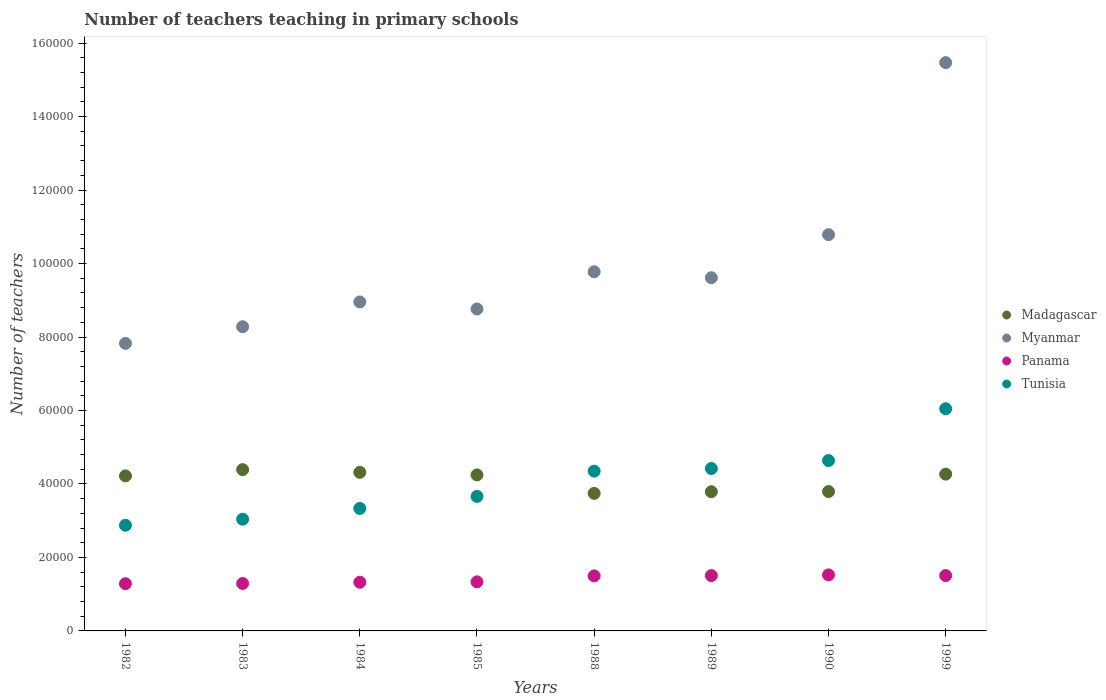What is the number of teachers teaching in primary schools in Tunisia in 1985?
Make the answer very short. 3.66e+04. Across all years, what is the maximum number of teachers teaching in primary schools in Madagascar?
Keep it short and to the point. 4.39e+04. Across all years, what is the minimum number of teachers teaching in primary schools in Tunisia?
Offer a very short reply. 2.88e+04. In which year was the number of teachers teaching in primary schools in Myanmar maximum?
Your response must be concise. 1999. What is the total number of teachers teaching in primary schools in Tunisia in the graph?
Offer a terse response. 3.24e+05. What is the difference between the number of teachers teaching in primary schools in Tunisia in 1984 and that in 1989?
Your response must be concise. -1.09e+04. What is the difference between the number of teachers teaching in primary schools in Myanmar in 1988 and the number of teachers teaching in primary schools in Panama in 1999?
Provide a short and direct response. 8.27e+04. What is the average number of teachers teaching in primary schools in Tunisia per year?
Offer a very short reply. 4.05e+04. In the year 1982, what is the difference between the number of teachers teaching in primary schools in Myanmar and number of teachers teaching in primary schools in Panama?
Keep it short and to the point. 6.54e+04. In how many years, is the number of teachers teaching in primary schools in Myanmar greater than 88000?
Keep it short and to the point. 5. What is the ratio of the number of teachers teaching in primary schools in Madagascar in 1985 to that in 1999?
Your answer should be very brief. 0.99. Is the number of teachers teaching in primary schools in Tunisia in 1984 less than that in 1990?
Your response must be concise. Yes. What is the difference between the highest and the second highest number of teachers teaching in primary schools in Tunisia?
Provide a succinct answer. 1.41e+04. What is the difference between the highest and the lowest number of teachers teaching in primary schools in Tunisia?
Offer a terse response. 3.17e+04. In how many years, is the number of teachers teaching in primary schools in Tunisia greater than the average number of teachers teaching in primary schools in Tunisia taken over all years?
Ensure brevity in your answer.  4. Is the sum of the number of teachers teaching in primary schools in Panama in 1983 and 1989 greater than the maximum number of teachers teaching in primary schools in Madagascar across all years?
Make the answer very short. No. Is it the case that in every year, the sum of the number of teachers teaching in primary schools in Tunisia and number of teachers teaching in primary schools in Madagascar  is greater than the sum of number of teachers teaching in primary schools in Myanmar and number of teachers teaching in primary schools in Panama?
Offer a very short reply. Yes. How many dotlines are there?
Your answer should be very brief. 4. How many years are there in the graph?
Ensure brevity in your answer.  8. Are the values on the major ticks of Y-axis written in scientific E-notation?
Your answer should be compact. No. Does the graph contain grids?
Provide a succinct answer. No. Where does the legend appear in the graph?
Provide a short and direct response. Center right. How are the legend labels stacked?
Make the answer very short. Vertical. What is the title of the graph?
Provide a short and direct response. Number of teachers teaching in primary schools. What is the label or title of the X-axis?
Provide a short and direct response. Years. What is the label or title of the Y-axis?
Make the answer very short. Number of teachers. What is the Number of teachers in Madagascar in 1982?
Keep it short and to the point. 4.22e+04. What is the Number of teachers in Myanmar in 1982?
Your response must be concise. 7.83e+04. What is the Number of teachers in Panama in 1982?
Offer a terse response. 1.29e+04. What is the Number of teachers of Tunisia in 1982?
Offer a very short reply. 2.88e+04. What is the Number of teachers in Madagascar in 1983?
Keep it short and to the point. 4.39e+04. What is the Number of teachers in Myanmar in 1983?
Keep it short and to the point. 8.28e+04. What is the Number of teachers of Panama in 1983?
Ensure brevity in your answer.  1.29e+04. What is the Number of teachers of Tunisia in 1983?
Keep it short and to the point. 3.04e+04. What is the Number of teachers in Madagascar in 1984?
Provide a short and direct response. 4.32e+04. What is the Number of teachers in Myanmar in 1984?
Provide a short and direct response. 8.95e+04. What is the Number of teachers of Panama in 1984?
Keep it short and to the point. 1.33e+04. What is the Number of teachers in Tunisia in 1984?
Your response must be concise. 3.33e+04. What is the Number of teachers of Madagascar in 1985?
Keep it short and to the point. 4.25e+04. What is the Number of teachers of Myanmar in 1985?
Ensure brevity in your answer.  8.76e+04. What is the Number of teachers of Panama in 1985?
Provide a short and direct response. 1.34e+04. What is the Number of teachers in Tunisia in 1985?
Keep it short and to the point. 3.66e+04. What is the Number of teachers of Madagascar in 1988?
Your response must be concise. 3.74e+04. What is the Number of teachers in Myanmar in 1988?
Give a very brief answer. 9.78e+04. What is the Number of teachers in Panama in 1988?
Provide a short and direct response. 1.50e+04. What is the Number of teachers of Tunisia in 1988?
Offer a terse response. 4.35e+04. What is the Number of teachers in Madagascar in 1989?
Your answer should be compact. 3.79e+04. What is the Number of teachers of Myanmar in 1989?
Your answer should be very brief. 9.61e+04. What is the Number of teachers in Panama in 1989?
Offer a very short reply. 1.51e+04. What is the Number of teachers in Tunisia in 1989?
Your answer should be compact. 4.42e+04. What is the Number of teachers in Madagascar in 1990?
Give a very brief answer. 3.79e+04. What is the Number of teachers in Myanmar in 1990?
Give a very brief answer. 1.08e+05. What is the Number of teachers in Panama in 1990?
Keep it short and to the point. 1.52e+04. What is the Number of teachers in Tunisia in 1990?
Provide a succinct answer. 4.64e+04. What is the Number of teachers in Madagascar in 1999?
Provide a succinct answer. 4.27e+04. What is the Number of teachers in Myanmar in 1999?
Offer a very short reply. 1.55e+05. What is the Number of teachers of Panama in 1999?
Your answer should be compact. 1.51e+04. What is the Number of teachers in Tunisia in 1999?
Offer a very short reply. 6.05e+04. Across all years, what is the maximum Number of teachers of Madagascar?
Your answer should be compact. 4.39e+04. Across all years, what is the maximum Number of teachers in Myanmar?
Your answer should be very brief. 1.55e+05. Across all years, what is the maximum Number of teachers of Panama?
Offer a terse response. 1.52e+04. Across all years, what is the maximum Number of teachers of Tunisia?
Keep it short and to the point. 6.05e+04. Across all years, what is the minimum Number of teachers in Madagascar?
Offer a very short reply. 3.74e+04. Across all years, what is the minimum Number of teachers of Myanmar?
Ensure brevity in your answer.  7.83e+04. Across all years, what is the minimum Number of teachers in Panama?
Make the answer very short. 1.29e+04. Across all years, what is the minimum Number of teachers of Tunisia?
Provide a succinct answer. 2.88e+04. What is the total Number of teachers in Madagascar in the graph?
Give a very brief answer. 3.28e+05. What is the total Number of teachers in Myanmar in the graph?
Offer a terse response. 7.95e+05. What is the total Number of teachers in Panama in the graph?
Make the answer very short. 1.13e+05. What is the total Number of teachers in Tunisia in the graph?
Offer a very short reply. 3.24e+05. What is the difference between the Number of teachers in Madagascar in 1982 and that in 1983?
Provide a short and direct response. -1701. What is the difference between the Number of teachers in Myanmar in 1982 and that in 1983?
Make the answer very short. -4534. What is the difference between the Number of teachers in Panama in 1982 and that in 1983?
Keep it short and to the point. -59. What is the difference between the Number of teachers in Tunisia in 1982 and that in 1983?
Offer a very short reply. -1647. What is the difference between the Number of teachers in Madagascar in 1982 and that in 1984?
Your answer should be compact. -960. What is the difference between the Number of teachers in Myanmar in 1982 and that in 1984?
Your answer should be very brief. -1.13e+04. What is the difference between the Number of teachers of Panama in 1982 and that in 1984?
Make the answer very short. -402. What is the difference between the Number of teachers of Tunisia in 1982 and that in 1984?
Provide a succinct answer. -4583. What is the difference between the Number of teachers of Madagascar in 1982 and that in 1985?
Your response must be concise. -265. What is the difference between the Number of teachers in Myanmar in 1982 and that in 1985?
Your answer should be very brief. -9366. What is the difference between the Number of teachers in Panama in 1982 and that in 1985?
Make the answer very short. -506. What is the difference between the Number of teachers in Tunisia in 1982 and that in 1985?
Your answer should be very brief. -7846. What is the difference between the Number of teachers of Madagascar in 1982 and that in 1988?
Ensure brevity in your answer.  4758. What is the difference between the Number of teachers of Myanmar in 1982 and that in 1988?
Your answer should be very brief. -1.95e+04. What is the difference between the Number of teachers in Panama in 1982 and that in 1988?
Make the answer very short. -2127. What is the difference between the Number of teachers in Tunisia in 1982 and that in 1988?
Ensure brevity in your answer.  -1.47e+04. What is the difference between the Number of teachers of Madagascar in 1982 and that in 1989?
Provide a succinct answer. 4303. What is the difference between the Number of teachers of Myanmar in 1982 and that in 1989?
Offer a very short reply. -1.79e+04. What is the difference between the Number of teachers of Panama in 1982 and that in 1989?
Provide a short and direct response. -2209. What is the difference between the Number of teachers of Tunisia in 1982 and that in 1989?
Your answer should be very brief. -1.54e+04. What is the difference between the Number of teachers of Madagascar in 1982 and that in 1990?
Give a very brief answer. 4265. What is the difference between the Number of teachers of Myanmar in 1982 and that in 1990?
Offer a very short reply. -2.96e+04. What is the difference between the Number of teachers of Panama in 1982 and that in 1990?
Your answer should be very brief. -2396. What is the difference between the Number of teachers in Tunisia in 1982 and that in 1990?
Give a very brief answer. -1.76e+04. What is the difference between the Number of teachers of Madagascar in 1982 and that in 1999?
Give a very brief answer. -481. What is the difference between the Number of teachers in Myanmar in 1982 and that in 1999?
Your answer should be compact. -7.64e+04. What is the difference between the Number of teachers in Panama in 1982 and that in 1999?
Offer a very short reply. -2216. What is the difference between the Number of teachers in Tunisia in 1982 and that in 1999?
Offer a very short reply. -3.17e+04. What is the difference between the Number of teachers in Madagascar in 1983 and that in 1984?
Ensure brevity in your answer.  741. What is the difference between the Number of teachers in Myanmar in 1983 and that in 1984?
Provide a succinct answer. -6740. What is the difference between the Number of teachers in Panama in 1983 and that in 1984?
Your answer should be very brief. -343. What is the difference between the Number of teachers in Tunisia in 1983 and that in 1984?
Provide a short and direct response. -2936. What is the difference between the Number of teachers of Madagascar in 1983 and that in 1985?
Ensure brevity in your answer.  1436. What is the difference between the Number of teachers of Myanmar in 1983 and that in 1985?
Keep it short and to the point. -4832. What is the difference between the Number of teachers in Panama in 1983 and that in 1985?
Provide a succinct answer. -447. What is the difference between the Number of teachers in Tunisia in 1983 and that in 1985?
Offer a very short reply. -6199. What is the difference between the Number of teachers in Madagascar in 1983 and that in 1988?
Offer a very short reply. 6459. What is the difference between the Number of teachers in Myanmar in 1983 and that in 1988?
Offer a very short reply. -1.50e+04. What is the difference between the Number of teachers in Panama in 1983 and that in 1988?
Provide a short and direct response. -2068. What is the difference between the Number of teachers of Tunisia in 1983 and that in 1988?
Your answer should be very brief. -1.31e+04. What is the difference between the Number of teachers of Madagascar in 1983 and that in 1989?
Your response must be concise. 6004. What is the difference between the Number of teachers in Myanmar in 1983 and that in 1989?
Keep it short and to the point. -1.33e+04. What is the difference between the Number of teachers of Panama in 1983 and that in 1989?
Keep it short and to the point. -2150. What is the difference between the Number of teachers in Tunisia in 1983 and that in 1989?
Make the answer very short. -1.38e+04. What is the difference between the Number of teachers of Madagascar in 1983 and that in 1990?
Your answer should be very brief. 5966. What is the difference between the Number of teachers in Myanmar in 1983 and that in 1990?
Your response must be concise. -2.51e+04. What is the difference between the Number of teachers in Panama in 1983 and that in 1990?
Your response must be concise. -2337. What is the difference between the Number of teachers of Tunisia in 1983 and that in 1990?
Offer a terse response. -1.60e+04. What is the difference between the Number of teachers of Madagascar in 1983 and that in 1999?
Offer a very short reply. 1220. What is the difference between the Number of teachers of Myanmar in 1983 and that in 1999?
Offer a terse response. -7.19e+04. What is the difference between the Number of teachers in Panama in 1983 and that in 1999?
Offer a terse response. -2157. What is the difference between the Number of teachers of Tunisia in 1983 and that in 1999?
Make the answer very short. -3.01e+04. What is the difference between the Number of teachers in Madagascar in 1984 and that in 1985?
Keep it short and to the point. 695. What is the difference between the Number of teachers of Myanmar in 1984 and that in 1985?
Offer a terse response. 1908. What is the difference between the Number of teachers in Panama in 1984 and that in 1985?
Make the answer very short. -104. What is the difference between the Number of teachers in Tunisia in 1984 and that in 1985?
Keep it short and to the point. -3263. What is the difference between the Number of teachers of Madagascar in 1984 and that in 1988?
Provide a short and direct response. 5718. What is the difference between the Number of teachers of Myanmar in 1984 and that in 1988?
Ensure brevity in your answer.  -8224. What is the difference between the Number of teachers of Panama in 1984 and that in 1988?
Make the answer very short. -1725. What is the difference between the Number of teachers in Tunisia in 1984 and that in 1988?
Offer a very short reply. -1.01e+04. What is the difference between the Number of teachers of Madagascar in 1984 and that in 1989?
Your answer should be very brief. 5263. What is the difference between the Number of teachers of Myanmar in 1984 and that in 1989?
Provide a short and direct response. -6600. What is the difference between the Number of teachers of Panama in 1984 and that in 1989?
Give a very brief answer. -1807. What is the difference between the Number of teachers in Tunisia in 1984 and that in 1989?
Provide a short and direct response. -1.09e+04. What is the difference between the Number of teachers in Madagascar in 1984 and that in 1990?
Your answer should be very brief. 5225. What is the difference between the Number of teachers in Myanmar in 1984 and that in 1990?
Keep it short and to the point. -1.83e+04. What is the difference between the Number of teachers in Panama in 1984 and that in 1990?
Make the answer very short. -1994. What is the difference between the Number of teachers of Tunisia in 1984 and that in 1990?
Your answer should be compact. -1.30e+04. What is the difference between the Number of teachers in Madagascar in 1984 and that in 1999?
Ensure brevity in your answer.  479. What is the difference between the Number of teachers of Myanmar in 1984 and that in 1999?
Make the answer very short. -6.51e+04. What is the difference between the Number of teachers of Panama in 1984 and that in 1999?
Make the answer very short. -1814. What is the difference between the Number of teachers in Tunisia in 1984 and that in 1999?
Your answer should be very brief. -2.71e+04. What is the difference between the Number of teachers of Madagascar in 1985 and that in 1988?
Your answer should be compact. 5023. What is the difference between the Number of teachers of Myanmar in 1985 and that in 1988?
Your response must be concise. -1.01e+04. What is the difference between the Number of teachers of Panama in 1985 and that in 1988?
Your answer should be very brief. -1621. What is the difference between the Number of teachers in Tunisia in 1985 and that in 1988?
Provide a succinct answer. -6880. What is the difference between the Number of teachers in Madagascar in 1985 and that in 1989?
Make the answer very short. 4568. What is the difference between the Number of teachers in Myanmar in 1985 and that in 1989?
Offer a very short reply. -8508. What is the difference between the Number of teachers in Panama in 1985 and that in 1989?
Your response must be concise. -1703. What is the difference between the Number of teachers of Tunisia in 1985 and that in 1989?
Your answer should be compact. -7598. What is the difference between the Number of teachers of Madagascar in 1985 and that in 1990?
Keep it short and to the point. 4530. What is the difference between the Number of teachers in Myanmar in 1985 and that in 1990?
Offer a very short reply. -2.02e+04. What is the difference between the Number of teachers of Panama in 1985 and that in 1990?
Provide a short and direct response. -1890. What is the difference between the Number of teachers of Tunisia in 1985 and that in 1990?
Your answer should be compact. -9756. What is the difference between the Number of teachers of Madagascar in 1985 and that in 1999?
Make the answer very short. -216. What is the difference between the Number of teachers of Myanmar in 1985 and that in 1999?
Your answer should be very brief. -6.71e+04. What is the difference between the Number of teachers in Panama in 1985 and that in 1999?
Provide a succinct answer. -1710. What is the difference between the Number of teachers of Tunisia in 1985 and that in 1999?
Your response must be concise. -2.39e+04. What is the difference between the Number of teachers in Madagascar in 1988 and that in 1989?
Provide a succinct answer. -455. What is the difference between the Number of teachers in Myanmar in 1988 and that in 1989?
Make the answer very short. 1624. What is the difference between the Number of teachers in Panama in 1988 and that in 1989?
Give a very brief answer. -82. What is the difference between the Number of teachers of Tunisia in 1988 and that in 1989?
Ensure brevity in your answer.  -718. What is the difference between the Number of teachers in Madagascar in 1988 and that in 1990?
Provide a succinct answer. -493. What is the difference between the Number of teachers in Myanmar in 1988 and that in 1990?
Keep it short and to the point. -1.01e+04. What is the difference between the Number of teachers in Panama in 1988 and that in 1990?
Give a very brief answer. -269. What is the difference between the Number of teachers of Tunisia in 1988 and that in 1990?
Provide a succinct answer. -2876. What is the difference between the Number of teachers in Madagascar in 1988 and that in 1999?
Ensure brevity in your answer.  -5239. What is the difference between the Number of teachers in Myanmar in 1988 and that in 1999?
Your response must be concise. -5.69e+04. What is the difference between the Number of teachers of Panama in 1988 and that in 1999?
Make the answer very short. -89. What is the difference between the Number of teachers in Tunisia in 1988 and that in 1999?
Provide a succinct answer. -1.70e+04. What is the difference between the Number of teachers in Madagascar in 1989 and that in 1990?
Offer a very short reply. -38. What is the difference between the Number of teachers in Myanmar in 1989 and that in 1990?
Provide a succinct answer. -1.17e+04. What is the difference between the Number of teachers of Panama in 1989 and that in 1990?
Offer a very short reply. -187. What is the difference between the Number of teachers in Tunisia in 1989 and that in 1990?
Provide a succinct answer. -2158. What is the difference between the Number of teachers of Madagascar in 1989 and that in 1999?
Provide a succinct answer. -4784. What is the difference between the Number of teachers of Myanmar in 1989 and that in 1999?
Offer a very short reply. -5.85e+04. What is the difference between the Number of teachers of Panama in 1989 and that in 1999?
Make the answer very short. -7. What is the difference between the Number of teachers of Tunisia in 1989 and that in 1999?
Your response must be concise. -1.63e+04. What is the difference between the Number of teachers of Madagascar in 1990 and that in 1999?
Give a very brief answer. -4746. What is the difference between the Number of teachers of Myanmar in 1990 and that in 1999?
Offer a terse response. -4.68e+04. What is the difference between the Number of teachers in Panama in 1990 and that in 1999?
Provide a short and direct response. 180. What is the difference between the Number of teachers in Tunisia in 1990 and that in 1999?
Provide a succinct answer. -1.41e+04. What is the difference between the Number of teachers in Madagascar in 1982 and the Number of teachers in Myanmar in 1983?
Make the answer very short. -4.06e+04. What is the difference between the Number of teachers in Madagascar in 1982 and the Number of teachers in Panama in 1983?
Your response must be concise. 2.93e+04. What is the difference between the Number of teachers in Madagascar in 1982 and the Number of teachers in Tunisia in 1983?
Offer a terse response. 1.18e+04. What is the difference between the Number of teachers in Myanmar in 1982 and the Number of teachers in Panama in 1983?
Give a very brief answer. 6.54e+04. What is the difference between the Number of teachers in Myanmar in 1982 and the Number of teachers in Tunisia in 1983?
Make the answer very short. 4.79e+04. What is the difference between the Number of teachers of Panama in 1982 and the Number of teachers of Tunisia in 1983?
Your answer should be very brief. -1.76e+04. What is the difference between the Number of teachers of Madagascar in 1982 and the Number of teachers of Myanmar in 1984?
Keep it short and to the point. -4.73e+04. What is the difference between the Number of teachers of Madagascar in 1982 and the Number of teachers of Panama in 1984?
Offer a terse response. 2.89e+04. What is the difference between the Number of teachers in Madagascar in 1982 and the Number of teachers in Tunisia in 1984?
Provide a succinct answer. 8850. What is the difference between the Number of teachers of Myanmar in 1982 and the Number of teachers of Panama in 1984?
Your answer should be compact. 6.50e+04. What is the difference between the Number of teachers of Myanmar in 1982 and the Number of teachers of Tunisia in 1984?
Offer a very short reply. 4.49e+04. What is the difference between the Number of teachers in Panama in 1982 and the Number of teachers in Tunisia in 1984?
Your response must be concise. -2.05e+04. What is the difference between the Number of teachers in Madagascar in 1982 and the Number of teachers in Myanmar in 1985?
Offer a very short reply. -4.54e+04. What is the difference between the Number of teachers in Madagascar in 1982 and the Number of teachers in Panama in 1985?
Give a very brief answer. 2.88e+04. What is the difference between the Number of teachers in Madagascar in 1982 and the Number of teachers in Tunisia in 1985?
Your response must be concise. 5587. What is the difference between the Number of teachers in Myanmar in 1982 and the Number of teachers in Panama in 1985?
Give a very brief answer. 6.49e+04. What is the difference between the Number of teachers in Myanmar in 1982 and the Number of teachers in Tunisia in 1985?
Your answer should be very brief. 4.17e+04. What is the difference between the Number of teachers of Panama in 1982 and the Number of teachers of Tunisia in 1985?
Provide a short and direct response. -2.38e+04. What is the difference between the Number of teachers of Madagascar in 1982 and the Number of teachers of Myanmar in 1988?
Provide a short and direct response. -5.56e+04. What is the difference between the Number of teachers of Madagascar in 1982 and the Number of teachers of Panama in 1988?
Offer a terse response. 2.72e+04. What is the difference between the Number of teachers of Madagascar in 1982 and the Number of teachers of Tunisia in 1988?
Your response must be concise. -1293. What is the difference between the Number of teachers of Myanmar in 1982 and the Number of teachers of Panama in 1988?
Ensure brevity in your answer.  6.33e+04. What is the difference between the Number of teachers in Myanmar in 1982 and the Number of teachers in Tunisia in 1988?
Offer a terse response. 3.48e+04. What is the difference between the Number of teachers in Panama in 1982 and the Number of teachers in Tunisia in 1988?
Ensure brevity in your answer.  -3.06e+04. What is the difference between the Number of teachers of Madagascar in 1982 and the Number of teachers of Myanmar in 1989?
Make the answer very short. -5.39e+04. What is the difference between the Number of teachers in Madagascar in 1982 and the Number of teachers in Panama in 1989?
Make the answer very short. 2.71e+04. What is the difference between the Number of teachers in Madagascar in 1982 and the Number of teachers in Tunisia in 1989?
Provide a succinct answer. -2011. What is the difference between the Number of teachers of Myanmar in 1982 and the Number of teachers of Panama in 1989?
Make the answer very short. 6.32e+04. What is the difference between the Number of teachers in Myanmar in 1982 and the Number of teachers in Tunisia in 1989?
Ensure brevity in your answer.  3.41e+04. What is the difference between the Number of teachers in Panama in 1982 and the Number of teachers in Tunisia in 1989?
Give a very brief answer. -3.14e+04. What is the difference between the Number of teachers in Madagascar in 1982 and the Number of teachers in Myanmar in 1990?
Offer a very short reply. -6.57e+04. What is the difference between the Number of teachers in Madagascar in 1982 and the Number of teachers in Panama in 1990?
Your response must be concise. 2.69e+04. What is the difference between the Number of teachers of Madagascar in 1982 and the Number of teachers of Tunisia in 1990?
Your response must be concise. -4169. What is the difference between the Number of teachers in Myanmar in 1982 and the Number of teachers in Panama in 1990?
Your answer should be compact. 6.30e+04. What is the difference between the Number of teachers of Myanmar in 1982 and the Number of teachers of Tunisia in 1990?
Give a very brief answer. 3.19e+04. What is the difference between the Number of teachers of Panama in 1982 and the Number of teachers of Tunisia in 1990?
Your answer should be very brief. -3.35e+04. What is the difference between the Number of teachers of Madagascar in 1982 and the Number of teachers of Myanmar in 1999?
Provide a short and direct response. -1.12e+05. What is the difference between the Number of teachers in Madagascar in 1982 and the Number of teachers in Panama in 1999?
Provide a succinct answer. 2.71e+04. What is the difference between the Number of teachers of Madagascar in 1982 and the Number of teachers of Tunisia in 1999?
Your answer should be very brief. -1.83e+04. What is the difference between the Number of teachers of Myanmar in 1982 and the Number of teachers of Panama in 1999?
Give a very brief answer. 6.32e+04. What is the difference between the Number of teachers of Myanmar in 1982 and the Number of teachers of Tunisia in 1999?
Provide a short and direct response. 1.78e+04. What is the difference between the Number of teachers in Panama in 1982 and the Number of teachers in Tunisia in 1999?
Provide a succinct answer. -4.76e+04. What is the difference between the Number of teachers of Madagascar in 1983 and the Number of teachers of Myanmar in 1984?
Give a very brief answer. -4.56e+04. What is the difference between the Number of teachers in Madagascar in 1983 and the Number of teachers in Panama in 1984?
Keep it short and to the point. 3.06e+04. What is the difference between the Number of teachers in Madagascar in 1983 and the Number of teachers in Tunisia in 1984?
Offer a very short reply. 1.06e+04. What is the difference between the Number of teachers in Myanmar in 1983 and the Number of teachers in Panama in 1984?
Offer a very short reply. 6.95e+04. What is the difference between the Number of teachers of Myanmar in 1983 and the Number of teachers of Tunisia in 1984?
Offer a very short reply. 4.95e+04. What is the difference between the Number of teachers of Panama in 1983 and the Number of teachers of Tunisia in 1984?
Ensure brevity in your answer.  -2.04e+04. What is the difference between the Number of teachers of Madagascar in 1983 and the Number of teachers of Myanmar in 1985?
Offer a very short reply. -4.37e+04. What is the difference between the Number of teachers of Madagascar in 1983 and the Number of teachers of Panama in 1985?
Ensure brevity in your answer.  3.05e+04. What is the difference between the Number of teachers in Madagascar in 1983 and the Number of teachers in Tunisia in 1985?
Make the answer very short. 7288. What is the difference between the Number of teachers of Myanmar in 1983 and the Number of teachers of Panama in 1985?
Make the answer very short. 6.94e+04. What is the difference between the Number of teachers of Myanmar in 1983 and the Number of teachers of Tunisia in 1985?
Your answer should be very brief. 4.62e+04. What is the difference between the Number of teachers in Panama in 1983 and the Number of teachers in Tunisia in 1985?
Provide a short and direct response. -2.37e+04. What is the difference between the Number of teachers in Madagascar in 1983 and the Number of teachers in Myanmar in 1988?
Ensure brevity in your answer.  -5.39e+04. What is the difference between the Number of teachers in Madagascar in 1983 and the Number of teachers in Panama in 1988?
Keep it short and to the point. 2.89e+04. What is the difference between the Number of teachers of Madagascar in 1983 and the Number of teachers of Tunisia in 1988?
Offer a very short reply. 408. What is the difference between the Number of teachers of Myanmar in 1983 and the Number of teachers of Panama in 1988?
Offer a terse response. 6.78e+04. What is the difference between the Number of teachers of Myanmar in 1983 and the Number of teachers of Tunisia in 1988?
Provide a short and direct response. 3.93e+04. What is the difference between the Number of teachers of Panama in 1983 and the Number of teachers of Tunisia in 1988?
Ensure brevity in your answer.  -3.06e+04. What is the difference between the Number of teachers of Madagascar in 1983 and the Number of teachers of Myanmar in 1989?
Give a very brief answer. -5.22e+04. What is the difference between the Number of teachers of Madagascar in 1983 and the Number of teachers of Panama in 1989?
Make the answer very short. 2.88e+04. What is the difference between the Number of teachers in Madagascar in 1983 and the Number of teachers in Tunisia in 1989?
Provide a succinct answer. -310. What is the difference between the Number of teachers in Myanmar in 1983 and the Number of teachers in Panama in 1989?
Your response must be concise. 6.77e+04. What is the difference between the Number of teachers of Myanmar in 1983 and the Number of teachers of Tunisia in 1989?
Your answer should be compact. 3.86e+04. What is the difference between the Number of teachers of Panama in 1983 and the Number of teachers of Tunisia in 1989?
Make the answer very short. -3.13e+04. What is the difference between the Number of teachers in Madagascar in 1983 and the Number of teachers in Myanmar in 1990?
Provide a short and direct response. -6.40e+04. What is the difference between the Number of teachers in Madagascar in 1983 and the Number of teachers in Panama in 1990?
Provide a succinct answer. 2.86e+04. What is the difference between the Number of teachers in Madagascar in 1983 and the Number of teachers in Tunisia in 1990?
Give a very brief answer. -2468. What is the difference between the Number of teachers in Myanmar in 1983 and the Number of teachers in Panama in 1990?
Offer a very short reply. 6.76e+04. What is the difference between the Number of teachers in Myanmar in 1983 and the Number of teachers in Tunisia in 1990?
Offer a very short reply. 3.64e+04. What is the difference between the Number of teachers of Panama in 1983 and the Number of teachers of Tunisia in 1990?
Your response must be concise. -3.35e+04. What is the difference between the Number of teachers in Madagascar in 1983 and the Number of teachers in Myanmar in 1999?
Offer a very short reply. -1.11e+05. What is the difference between the Number of teachers in Madagascar in 1983 and the Number of teachers in Panama in 1999?
Offer a very short reply. 2.88e+04. What is the difference between the Number of teachers in Madagascar in 1983 and the Number of teachers in Tunisia in 1999?
Provide a short and direct response. -1.66e+04. What is the difference between the Number of teachers of Myanmar in 1983 and the Number of teachers of Panama in 1999?
Your answer should be compact. 6.77e+04. What is the difference between the Number of teachers in Myanmar in 1983 and the Number of teachers in Tunisia in 1999?
Your answer should be compact. 2.23e+04. What is the difference between the Number of teachers in Panama in 1983 and the Number of teachers in Tunisia in 1999?
Ensure brevity in your answer.  -4.76e+04. What is the difference between the Number of teachers in Madagascar in 1984 and the Number of teachers in Myanmar in 1985?
Your answer should be very brief. -4.45e+04. What is the difference between the Number of teachers of Madagascar in 1984 and the Number of teachers of Panama in 1985?
Your answer should be compact. 2.98e+04. What is the difference between the Number of teachers of Madagascar in 1984 and the Number of teachers of Tunisia in 1985?
Keep it short and to the point. 6547. What is the difference between the Number of teachers in Myanmar in 1984 and the Number of teachers in Panama in 1985?
Keep it short and to the point. 7.62e+04. What is the difference between the Number of teachers in Myanmar in 1984 and the Number of teachers in Tunisia in 1985?
Keep it short and to the point. 5.29e+04. What is the difference between the Number of teachers of Panama in 1984 and the Number of teachers of Tunisia in 1985?
Make the answer very short. -2.34e+04. What is the difference between the Number of teachers in Madagascar in 1984 and the Number of teachers in Myanmar in 1988?
Make the answer very short. -5.46e+04. What is the difference between the Number of teachers in Madagascar in 1984 and the Number of teachers in Panama in 1988?
Give a very brief answer. 2.82e+04. What is the difference between the Number of teachers in Madagascar in 1984 and the Number of teachers in Tunisia in 1988?
Make the answer very short. -333. What is the difference between the Number of teachers of Myanmar in 1984 and the Number of teachers of Panama in 1988?
Keep it short and to the point. 7.46e+04. What is the difference between the Number of teachers of Myanmar in 1984 and the Number of teachers of Tunisia in 1988?
Keep it short and to the point. 4.60e+04. What is the difference between the Number of teachers in Panama in 1984 and the Number of teachers in Tunisia in 1988?
Your answer should be very brief. -3.02e+04. What is the difference between the Number of teachers of Madagascar in 1984 and the Number of teachers of Myanmar in 1989?
Give a very brief answer. -5.30e+04. What is the difference between the Number of teachers of Madagascar in 1984 and the Number of teachers of Panama in 1989?
Your answer should be compact. 2.81e+04. What is the difference between the Number of teachers in Madagascar in 1984 and the Number of teachers in Tunisia in 1989?
Your answer should be compact. -1051. What is the difference between the Number of teachers of Myanmar in 1984 and the Number of teachers of Panama in 1989?
Provide a succinct answer. 7.45e+04. What is the difference between the Number of teachers in Myanmar in 1984 and the Number of teachers in Tunisia in 1989?
Your answer should be very brief. 4.53e+04. What is the difference between the Number of teachers of Panama in 1984 and the Number of teachers of Tunisia in 1989?
Offer a very short reply. -3.10e+04. What is the difference between the Number of teachers of Madagascar in 1984 and the Number of teachers of Myanmar in 1990?
Make the answer very short. -6.47e+04. What is the difference between the Number of teachers of Madagascar in 1984 and the Number of teachers of Panama in 1990?
Your answer should be very brief. 2.79e+04. What is the difference between the Number of teachers in Madagascar in 1984 and the Number of teachers in Tunisia in 1990?
Your response must be concise. -3209. What is the difference between the Number of teachers of Myanmar in 1984 and the Number of teachers of Panama in 1990?
Make the answer very short. 7.43e+04. What is the difference between the Number of teachers of Myanmar in 1984 and the Number of teachers of Tunisia in 1990?
Offer a very short reply. 4.32e+04. What is the difference between the Number of teachers in Panama in 1984 and the Number of teachers in Tunisia in 1990?
Keep it short and to the point. -3.31e+04. What is the difference between the Number of teachers in Madagascar in 1984 and the Number of teachers in Myanmar in 1999?
Make the answer very short. -1.12e+05. What is the difference between the Number of teachers in Madagascar in 1984 and the Number of teachers in Panama in 1999?
Offer a very short reply. 2.81e+04. What is the difference between the Number of teachers in Madagascar in 1984 and the Number of teachers in Tunisia in 1999?
Provide a succinct answer. -1.73e+04. What is the difference between the Number of teachers in Myanmar in 1984 and the Number of teachers in Panama in 1999?
Your response must be concise. 7.45e+04. What is the difference between the Number of teachers in Myanmar in 1984 and the Number of teachers in Tunisia in 1999?
Offer a very short reply. 2.91e+04. What is the difference between the Number of teachers in Panama in 1984 and the Number of teachers in Tunisia in 1999?
Provide a short and direct response. -4.72e+04. What is the difference between the Number of teachers in Madagascar in 1985 and the Number of teachers in Myanmar in 1988?
Offer a very short reply. -5.53e+04. What is the difference between the Number of teachers of Madagascar in 1985 and the Number of teachers of Panama in 1988?
Your answer should be compact. 2.75e+04. What is the difference between the Number of teachers in Madagascar in 1985 and the Number of teachers in Tunisia in 1988?
Make the answer very short. -1028. What is the difference between the Number of teachers in Myanmar in 1985 and the Number of teachers in Panama in 1988?
Make the answer very short. 7.27e+04. What is the difference between the Number of teachers of Myanmar in 1985 and the Number of teachers of Tunisia in 1988?
Ensure brevity in your answer.  4.41e+04. What is the difference between the Number of teachers in Panama in 1985 and the Number of teachers in Tunisia in 1988?
Give a very brief answer. -3.01e+04. What is the difference between the Number of teachers of Madagascar in 1985 and the Number of teachers of Myanmar in 1989?
Offer a terse response. -5.37e+04. What is the difference between the Number of teachers of Madagascar in 1985 and the Number of teachers of Panama in 1989?
Your response must be concise. 2.74e+04. What is the difference between the Number of teachers of Madagascar in 1985 and the Number of teachers of Tunisia in 1989?
Your answer should be compact. -1746. What is the difference between the Number of teachers in Myanmar in 1985 and the Number of teachers in Panama in 1989?
Your response must be concise. 7.26e+04. What is the difference between the Number of teachers of Myanmar in 1985 and the Number of teachers of Tunisia in 1989?
Ensure brevity in your answer.  4.34e+04. What is the difference between the Number of teachers in Panama in 1985 and the Number of teachers in Tunisia in 1989?
Your answer should be compact. -3.08e+04. What is the difference between the Number of teachers in Madagascar in 1985 and the Number of teachers in Myanmar in 1990?
Provide a short and direct response. -6.54e+04. What is the difference between the Number of teachers of Madagascar in 1985 and the Number of teachers of Panama in 1990?
Offer a terse response. 2.72e+04. What is the difference between the Number of teachers in Madagascar in 1985 and the Number of teachers in Tunisia in 1990?
Offer a very short reply. -3904. What is the difference between the Number of teachers of Myanmar in 1985 and the Number of teachers of Panama in 1990?
Offer a very short reply. 7.24e+04. What is the difference between the Number of teachers in Myanmar in 1985 and the Number of teachers in Tunisia in 1990?
Offer a very short reply. 4.13e+04. What is the difference between the Number of teachers in Panama in 1985 and the Number of teachers in Tunisia in 1990?
Your answer should be very brief. -3.30e+04. What is the difference between the Number of teachers of Madagascar in 1985 and the Number of teachers of Myanmar in 1999?
Your answer should be compact. -1.12e+05. What is the difference between the Number of teachers in Madagascar in 1985 and the Number of teachers in Panama in 1999?
Your answer should be compact. 2.74e+04. What is the difference between the Number of teachers of Madagascar in 1985 and the Number of teachers of Tunisia in 1999?
Your answer should be very brief. -1.80e+04. What is the difference between the Number of teachers in Myanmar in 1985 and the Number of teachers in Panama in 1999?
Offer a terse response. 7.26e+04. What is the difference between the Number of teachers of Myanmar in 1985 and the Number of teachers of Tunisia in 1999?
Your answer should be compact. 2.72e+04. What is the difference between the Number of teachers in Panama in 1985 and the Number of teachers in Tunisia in 1999?
Ensure brevity in your answer.  -4.71e+04. What is the difference between the Number of teachers in Madagascar in 1988 and the Number of teachers in Myanmar in 1989?
Keep it short and to the point. -5.87e+04. What is the difference between the Number of teachers in Madagascar in 1988 and the Number of teachers in Panama in 1989?
Offer a very short reply. 2.24e+04. What is the difference between the Number of teachers of Madagascar in 1988 and the Number of teachers of Tunisia in 1989?
Your answer should be compact. -6769. What is the difference between the Number of teachers of Myanmar in 1988 and the Number of teachers of Panama in 1989?
Provide a succinct answer. 8.27e+04. What is the difference between the Number of teachers of Myanmar in 1988 and the Number of teachers of Tunisia in 1989?
Your answer should be compact. 5.36e+04. What is the difference between the Number of teachers in Panama in 1988 and the Number of teachers in Tunisia in 1989?
Give a very brief answer. -2.92e+04. What is the difference between the Number of teachers of Madagascar in 1988 and the Number of teachers of Myanmar in 1990?
Provide a succinct answer. -7.04e+04. What is the difference between the Number of teachers in Madagascar in 1988 and the Number of teachers in Panama in 1990?
Provide a short and direct response. 2.22e+04. What is the difference between the Number of teachers of Madagascar in 1988 and the Number of teachers of Tunisia in 1990?
Your answer should be very brief. -8927. What is the difference between the Number of teachers in Myanmar in 1988 and the Number of teachers in Panama in 1990?
Give a very brief answer. 8.25e+04. What is the difference between the Number of teachers in Myanmar in 1988 and the Number of teachers in Tunisia in 1990?
Ensure brevity in your answer.  5.14e+04. What is the difference between the Number of teachers in Panama in 1988 and the Number of teachers in Tunisia in 1990?
Offer a very short reply. -3.14e+04. What is the difference between the Number of teachers in Madagascar in 1988 and the Number of teachers in Myanmar in 1999?
Provide a short and direct response. -1.17e+05. What is the difference between the Number of teachers of Madagascar in 1988 and the Number of teachers of Panama in 1999?
Give a very brief answer. 2.24e+04. What is the difference between the Number of teachers in Madagascar in 1988 and the Number of teachers in Tunisia in 1999?
Offer a very short reply. -2.30e+04. What is the difference between the Number of teachers in Myanmar in 1988 and the Number of teachers in Panama in 1999?
Make the answer very short. 8.27e+04. What is the difference between the Number of teachers in Myanmar in 1988 and the Number of teachers in Tunisia in 1999?
Keep it short and to the point. 3.73e+04. What is the difference between the Number of teachers in Panama in 1988 and the Number of teachers in Tunisia in 1999?
Provide a short and direct response. -4.55e+04. What is the difference between the Number of teachers of Madagascar in 1989 and the Number of teachers of Myanmar in 1990?
Keep it short and to the point. -7.00e+04. What is the difference between the Number of teachers of Madagascar in 1989 and the Number of teachers of Panama in 1990?
Give a very brief answer. 2.26e+04. What is the difference between the Number of teachers in Madagascar in 1989 and the Number of teachers in Tunisia in 1990?
Offer a very short reply. -8472. What is the difference between the Number of teachers in Myanmar in 1989 and the Number of teachers in Panama in 1990?
Provide a succinct answer. 8.09e+04. What is the difference between the Number of teachers in Myanmar in 1989 and the Number of teachers in Tunisia in 1990?
Make the answer very short. 4.98e+04. What is the difference between the Number of teachers in Panama in 1989 and the Number of teachers in Tunisia in 1990?
Provide a short and direct response. -3.13e+04. What is the difference between the Number of teachers in Madagascar in 1989 and the Number of teachers in Myanmar in 1999?
Provide a succinct answer. -1.17e+05. What is the difference between the Number of teachers of Madagascar in 1989 and the Number of teachers of Panama in 1999?
Give a very brief answer. 2.28e+04. What is the difference between the Number of teachers of Madagascar in 1989 and the Number of teachers of Tunisia in 1999?
Provide a short and direct response. -2.26e+04. What is the difference between the Number of teachers in Myanmar in 1989 and the Number of teachers in Panama in 1999?
Your answer should be compact. 8.11e+04. What is the difference between the Number of teachers of Myanmar in 1989 and the Number of teachers of Tunisia in 1999?
Your response must be concise. 3.57e+04. What is the difference between the Number of teachers in Panama in 1989 and the Number of teachers in Tunisia in 1999?
Provide a short and direct response. -4.54e+04. What is the difference between the Number of teachers of Madagascar in 1990 and the Number of teachers of Myanmar in 1999?
Your answer should be compact. -1.17e+05. What is the difference between the Number of teachers of Madagascar in 1990 and the Number of teachers of Panama in 1999?
Your answer should be very brief. 2.29e+04. What is the difference between the Number of teachers of Madagascar in 1990 and the Number of teachers of Tunisia in 1999?
Ensure brevity in your answer.  -2.25e+04. What is the difference between the Number of teachers in Myanmar in 1990 and the Number of teachers in Panama in 1999?
Your response must be concise. 9.28e+04. What is the difference between the Number of teachers of Myanmar in 1990 and the Number of teachers of Tunisia in 1999?
Your answer should be very brief. 4.74e+04. What is the difference between the Number of teachers in Panama in 1990 and the Number of teachers in Tunisia in 1999?
Provide a short and direct response. -4.52e+04. What is the average Number of teachers in Madagascar per year?
Ensure brevity in your answer.  4.10e+04. What is the average Number of teachers in Myanmar per year?
Make the answer very short. 9.93e+04. What is the average Number of teachers of Panama per year?
Make the answer very short. 1.41e+04. What is the average Number of teachers in Tunisia per year?
Provide a succinct answer. 4.05e+04. In the year 1982, what is the difference between the Number of teachers in Madagascar and Number of teachers in Myanmar?
Your answer should be very brief. -3.61e+04. In the year 1982, what is the difference between the Number of teachers of Madagascar and Number of teachers of Panama?
Your answer should be compact. 2.93e+04. In the year 1982, what is the difference between the Number of teachers of Madagascar and Number of teachers of Tunisia?
Your answer should be compact. 1.34e+04. In the year 1982, what is the difference between the Number of teachers in Myanmar and Number of teachers in Panama?
Keep it short and to the point. 6.54e+04. In the year 1982, what is the difference between the Number of teachers in Myanmar and Number of teachers in Tunisia?
Your answer should be very brief. 4.95e+04. In the year 1982, what is the difference between the Number of teachers in Panama and Number of teachers in Tunisia?
Your answer should be compact. -1.59e+04. In the year 1983, what is the difference between the Number of teachers of Madagascar and Number of teachers of Myanmar?
Give a very brief answer. -3.89e+04. In the year 1983, what is the difference between the Number of teachers in Madagascar and Number of teachers in Panama?
Provide a short and direct response. 3.10e+04. In the year 1983, what is the difference between the Number of teachers in Madagascar and Number of teachers in Tunisia?
Give a very brief answer. 1.35e+04. In the year 1983, what is the difference between the Number of teachers in Myanmar and Number of teachers in Panama?
Give a very brief answer. 6.99e+04. In the year 1983, what is the difference between the Number of teachers of Myanmar and Number of teachers of Tunisia?
Provide a succinct answer. 5.24e+04. In the year 1983, what is the difference between the Number of teachers in Panama and Number of teachers in Tunisia?
Keep it short and to the point. -1.75e+04. In the year 1984, what is the difference between the Number of teachers in Madagascar and Number of teachers in Myanmar?
Provide a short and direct response. -4.64e+04. In the year 1984, what is the difference between the Number of teachers of Madagascar and Number of teachers of Panama?
Offer a terse response. 2.99e+04. In the year 1984, what is the difference between the Number of teachers of Madagascar and Number of teachers of Tunisia?
Offer a very short reply. 9810. In the year 1984, what is the difference between the Number of teachers in Myanmar and Number of teachers in Panama?
Provide a succinct answer. 7.63e+04. In the year 1984, what is the difference between the Number of teachers in Myanmar and Number of teachers in Tunisia?
Provide a short and direct response. 5.62e+04. In the year 1984, what is the difference between the Number of teachers in Panama and Number of teachers in Tunisia?
Ensure brevity in your answer.  -2.01e+04. In the year 1985, what is the difference between the Number of teachers of Madagascar and Number of teachers of Myanmar?
Ensure brevity in your answer.  -4.52e+04. In the year 1985, what is the difference between the Number of teachers in Madagascar and Number of teachers in Panama?
Offer a terse response. 2.91e+04. In the year 1985, what is the difference between the Number of teachers of Madagascar and Number of teachers of Tunisia?
Your answer should be compact. 5852. In the year 1985, what is the difference between the Number of teachers of Myanmar and Number of teachers of Panama?
Make the answer very short. 7.43e+04. In the year 1985, what is the difference between the Number of teachers of Myanmar and Number of teachers of Tunisia?
Your answer should be compact. 5.10e+04. In the year 1985, what is the difference between the Number of teachers of Panama and Number of teachers of Tunisia?
Make the answer very short. -2.33e+04. In the year 1988, what is the difference between the Number of teachers of Madagascar and Number of teachers of Myanmar?
Your answer should be very brief. -6.03e+04. In the year 1988, what is the difference between the Number of teachers of Madagascar and Number of teachers of Panama?
Give a very brief answer. 2.25e+04. In the year 1988, what is the difference between the Number of teachers of Madagascar and Number of teachers of Tunisia?
Your answer should be compact. -6051. In the year 1988, what is the difference between the Number of teachers of Myanmar and Number of teachers of Panama?
Your answer should be compact. 8.28e+04. In the year 1988, what is the difference between the Number of teachers of Myanmar and Number of teachers of Tunisia?
Make the answer very short. 5.43e+04. In the year 1988, what is the difference between the Number of teachers in Panama and Number of teachers in Tunisia?
Your answer should be very brief. -2.85e+04. In the year 1989, what is the difference between the Number of teachers in Madagascar and Number of teachers in Myanmar?
Make the answer very short. -5.82e+04. In the year 1989, what is the difference between the Number of teachers of Madagascar and Number of teachers of Panama?
Your answer should be very brief. 2.28e+04. In the year 1989, what is the difference between the Number of teachers of Madagascar and Number of teachers of Tunisia?
Your answer should be compact. -6314. In the year 1989, what is the difference between the Number of teachers in Myanmar and Number of teachers in Panama?
Your answer should be compact. 8.11e+04. In the year 1989, what is the difference between the Number of teachers in Myanmar and Number of teachers in Tunisia?
Give a very brief answer. 5.19e+04. In the year 1989, what is the difference between the Number of teachers in Panama and Number of teachers in Tunisia?
Provide a short and direct response. -2.91e+04. In the year 1990, what is the difference between the Number of teachers of Madagascar and Number of teachers of Myanmar?
Your response must be concise. -6.99e+04. In the year 1990, what is the difference between the Number of teachers of Madagascar and Number of teachers of Panama?
Your answer should be compact. 2.27e+04. In the year 1990, what is the difference between the Number of teachers in Madagascar and Number of teachers in Tunisia?
Keep it short and to the point. -8434. In the year 1990, what is the difference between the Number of teachers of Myanmar and Number of teachers of Panama?
Offer a terse response. 9.26e+04. In the year 1990, what is the difference between the Number of teachers of Myanmar and Number of teachers of Tunisia?
Keep it short and to the point. 6.15e+04. In the year 1990, what is the difference between the Number of teachers in Panama and Number of teachers in Tunisia?
Offer a terse response. -3.11e+04. In the year 1999, what is the difference between the Number of teachers in Madagascar and Number of teachers in Myanmar?
Provide a succinct answer. -1.12e+05. In the year 1999, what is the difference between the Number of teachers in Madagascar and Number of teachers in Panama?
Ensure brevity in your answer.  2.76e+04. In the year 1999, what is the difference between the Number of teachers of Madagascar and Number of teachers of Tunisia?
Provide a short and direct response. -1.78e+04. In the year 1999, what is the difference between the Number of teachers in Myanmar and Number of teachers in Panama?
Your response must be concise. 1.40e+05. In the year 1999, what is the difference between the Number of teachers of Myanmar and Number of teachers of Tunisia?
Give a very brief answer. 9.42e+04. In the year 1999, what is the difference between the Number of teachers of Panama and Number of teachers of Tunisia?
Give a very brief answer. -4.54e+04. What is the ratio of the Number of teachers in Madagascar in 1982 to that in 1983?
Provide a succinct answer. 0.96. What is the ratio of the Number of teachers in Myanmar in 1982 to that in 1983?
Provide a short and direct response. 0.95. What is the ratio of the Number of teachers of Tunisia in 1982 to that in 1983?
Ensure brevity in your answer.  0.95. What is the ratio of the Number of teachers in Madagascar in 1982 to that in 1984?
Your answer should be very brief. 0.98. What is the ratio of the Number of teachers of Myanmar in 1982 to that in 1984?
Keep it short and to the point. 0.87. What is the ratio of the Number of teachers of Panama in 1982 to that in 1984?
Provide a succinct answer. 0.97. What is the ratio of the Number of teachers in Tunisia in 1982 to that in 1984?
Offer a terse response. 0.86. What is the ratio of the Number of teachers of Madagascar in 1982 to that in 1985?
Offer a very short reply. 0.99. What is the ratio of the Number of teachers of Myanmar in 1982 to that in 1985?
Make the answer very short. 0.89. What is the ratio of the Number of teachers of Panama in 1982 to that in 1985?
Provide a succinct answer. 0.96. What is the ratio of the Number of teachers in Tunisia in 1982 to that in 1985?
Provide a succinct answer. 0.79. What is the ratio of the Number of teachers of Madagascar in 1982 to that in 1988?
Provide a short and direct response. 1.13. What is the ratio of the Number of teachers of Myanmar in 1982 to that in 1988?
Provide a succinct answer. 0.8. What is the ratio of the Number of teachers of Panama in 1982 to that in 1988?
Provide a succinct answer. 0.86. What is the ratio of the Number of teachers in Tunisia in 1982 to that in 1988?
Your response must be concise. 0.66. What is the ratio of the Number of teachers in Madagascar in 1982 to that in 1989?
Offer a terse response. 1.11. What is the ratio of the Number of teachers in Myanmar in 1982 to that in 1989?
Your response must be concise. 0.81. What is the ratio of the Number of teachers of Panama in 1982 to that in 1989?
Your response must be concise. 0.85. What is the ratio of the Number of teachers of Tunisia in 1982 to that in 1989?
Your answer should be compact. 0.65. What is the ratio of the Number of teachers of Madagascar in 1982 to that in 1990?
Provide a short and direct response. 1.11. What is the ratio of the Number of teachers of Myanmar in 1982 to that in 1990?
Offer a very short reply. 0.73. What is the ratio of the Number of teachers in Panama in 1982 to that in 1990?
Your answer should be very brief. 0.84. What is the ratio of the Number of teachers of Tunisia in 1982 to that in 1990?
Offer a terse response. 0.62. What is the ratio of the Number of teachers of Madagascar in 1982 to that in 1999?
Offer a terse response. 0.99. What is the ratio of the Number of teachers of Myanmar in 1982 to that in 1999?
Make the answer very short. 0.51. What is the ratio of the Number of teachers of Panama in 1982 to that in 1999?
Your response must be concise. 0.85. What is the ratio of the Number of teachers in Tunisia in 1982 to that in 1999?
Ensure brevity in your answer.  0.48. What is the ratio of the Number of teachers in Madagascar in 1983 to that in 1984?
Your answer should be very brief. 1.02. What is the ratio of the Number of teachers of Myanmar in 1983 to that in 1984?
Offer a terse response. 0.92. What is the ratio of the Number of teachers in Panama in 1983 to that in 1984?
Give a very brief answer. 0.97. What is the ratio of the Number of teachers in Tunisia in 1983 to that in 1984?
Provide a succinct answer. 0.91. What is the ratio of the Number of teachers in Madagascar in 1983 to that in 1985?
Offer a terse response. 1.03. What is the ratio of the Number of teachers of Myanmar in 1983 to that in 1985?
Offer a terse response. 0.94. What is the ratio of the Number of teachers of Panama in 1983 to that in 1985?
Make the answer very short. 0.97. What is the ratio of the Number of teachers in Tunisia in 1983 to that in 1985?
Your response must be concise. 0.83. What is the ratio of the Number of teachers of Madagascar in 1983 to that in 1988?
Provide a short and direct response. 1.17. What is the ratio of the Number of teachers of Myanmar in 1983 to that in 1988?
Your response must be concise. 0.85. What is the ratio of the Number of teachers of Panama in 1983 to that in 1988?
Make the answer very short. 0.86. What is the ratio of the Number of teachers of Tunisia in 1983 to that in 1988?
Your response must be concise. 0.7. What is the ratio of the Number of teachers of Madagascar in 1983 to that in 1989?
Offer a very short reply. 1.16. What is the ratio of the Number of teachers of Myanmar in 1983 to that in 1989?
Your answer should be compact. 0.86. What is the ratio of the Number of teachers of Panama in 1983 to that in 1989?
Provide a succinct answer. 0.86. What is the ratio of the Number of teachers of Tunisia in 1983 to that in 1989?
Make the answer very short. 0.69. What is the ratio of the Number of teachers of Madagascar in 1983 to that in 1990?
Provide a short and direct response. 1.16. What is the ratio of the Number of teachers in Myanmar in 1983 to that in 1990?
Offer a terse response. 0.77. What is the ratio of the Number of teachers of Panama in 1983 to that in 1990?
Provide a short and direct response. 0.85. What is the ratio of the Number of teachers of Tunisia in 1983 to that in 1990?
Your answer should be compact. 0.66. What is the ratio of the Number of teachers of Madagascar in 1983 to that in 1999?
Keep it short and to the point. 1.03. What is the ratio of the Number of teachers of Myanmar in 1983 to that in 1999?
Give a very brief answer. 0.54. What is the ratio of the Number of teachers of Panama in 1983 to that in 1999?
Keep it short and to the point. 0.86. What is the ratio of the Number of teachers of Tunisia in 1983 to that in 1999?
Ensure brevity in your answer.  0.5. What is the ratio of the Number of teachers in Madagascar in 1984 to that in 1985?
Make the answer very short. 1.02. What is the ratio of the Number of teachers in Myanmar in 1984 to that in 1985?
Keep it short and to the point. 1.02. What is the ratio of the Number of teachers of Panama in 1984 to that in 1985?
Keep it short and to the point. 0.99. What is the ratio of the Number of teachers of Tunisia in 1984 to that in 1985?
Keep it short and to the point. 0.91. What is the ratio of the Number of teachers in Madagascar in 1984 to that in 1988?
Your response must be concise. 1.15. What is the ratio of the Number of teachers of Myanmar in 1984 to that in 1988?
Offer a very short reply. 0.92. What is the ratio of the Number of teachers in Panama in 1984 to that in 1988?
Provide a succinct answer. 0.88. What is the ratio of the Number of teachers in Tunisia in 1984 to that in 1988?
Keep it short and to the point. 0.77. What is the ratio of the Number of teachers in Madagascar in 1984 to that in 1989?
Provide a succinct answer. 1.14. What is the ratio of the Number of teachers of Myanmar in 1984 to that in 1989?
Make the answer very short. 0.93. What is the ratio of the Number of teachers in Tunisia in 1984 to that in 1989?
Keep it short and to the point. 0.75. What is the ratio of the Number of teachers of Madagascar in 1984 to that in 1990?
Your response must be concise. 1.14. What is the ratio of the Number of teachers of Myanmar in 1984 to that in 1990?
Provide a short and direct response. 0.83. What is the ratio of the Number of teachers in Panama in 1984 to that in 1990?
Ensure brevity in your answer.  0.87. What is the ratio of the Number of teachers of Tunisia in 1984 to that in 1990?
Offer a very short reply. 0.72. What is the ratio of the Number of teachers of Madagascar in 1984 to that in 1999?
Provide a short and direct response. 1.01. What is the ratio of the Number of teachers of Myanmar in 1984 to that in 1999?
Provide a short and direct response. 0.58. What is the ratio of the Number of teachers in Panama in 1984 to that in 1999?
Your answer should be very brief. 0.88. What is the ratio of the Number of teachers of Tunisia in 1984 to that in 1999?
Your answer should be very brief. 0.55. What is the ratio of the Number of teachers in Madagascar in 1985 to that in 1988?
Your response must be concise. 1.13. What is the ratio of the Number of teachers of Myanmar in 1985 to that in 1988?
Provide a short and direct response. 0.9. What is the ratio of the Number of teachers in Panama in 1985 to that in 1988?
Your response must be concise. 0.89. What is the ratio of the Number of teachers of Tunisia in 1985 to that in 1988?
Offer a very short reply. 0.84. What is the ratio of the Number of teachers in Madagascar in 1985 to that in 1989?
Your answer should be compact. 1.12. What is the ratio of the Number of teachers in Myanmar in 1985 to that in 1989?
Offer a very short reply. 0.91. What is the ratio of the Number of teachers of Panama in 1985 to that in 1989?
Your response must be concise. 0.89. What is the ratio of the Number of teachers of Tunisia in 1985 to that in 1989?
Provide a succinct answer. 0.83. What is the ratio of the Number of teachers in Madagascar in 1985 to that in 1990?
Keep it short and to the point. 1.12. What is the ratio of the Number of teachers in Myanmar in 1985 to that in 1990?
Your answer should be compact. 0.81. What is the ratio of the Number of teachers in Panama in 1985 to that in 1990?
Keep it short and to the point. 0.88. What is the ratio of the Number of teachers in Tunisia in 1985 to that in 1990?
Offer a very short reply. 0.79. What is the ratio of the Number of teachers of Madagascar in 1985 to that in 1999?
Offer a terse response. 0.99. What is the ratio of the Number of teachers of Myanmar in 1985 to that in 1999?
Provide a succinct answer. 0.57. What is the ratio of the Number of teachers in Panama in 1985 to that in 1999?
Your response must be concise. 0.89. What is the ratio of the Number of teachers in Tunisia in 1985 to that in 1999?
Ensure brevity in your answer.  0.61. What is the ratio of the Number of teachers of Madagascar in 1988 to that in 1989?
Keep it short and to the point. 0.99. What is the ratio of the Number of teachers in Myanmar in 1988 to that in 1989?
Give a very brief answer. 1.02. What is the ratio of the Number of teachers of Tunisia in 1988 to that in 1989?
Provide a succinct answer. 0.98. What is the ratio of the Number of teachers in Madagascar in 1988 to that in 1990?
Make the answer very short. 0.99. What is the ratio of the Number of teachers of Myanmar in 1988 to that in 1990?
Your answer should be very brief. 0.91. What is the ratio of the Number of teachers of Panama in 1988 to that in 1990?
Provide a short and direct response. 0.98. What is the ratio of the Number of teachers in Tunisia in 1988 to that in 1990?
Your response must be concise. 0.94. What is the ratio of the Number of teachers of Madagascar in 1988 to that in 1999?
Offer a terse response. 0.88. What is the ratio of the Number of teachers in Myanmar in 1988 to that in 1999?
Your response must be concise. 0.63. What is the ratio of the Number of teachers of Panama in 1988 to that in 1999?
Your answer should be compact. 0.99. What is the ratio of the Number of teachers in Tunisia in 1988 to that in 1999?
Ensure brevity in your answer.  0.72. What is the ratio of the Number of teachers of Myanmar in 1989 to that in 1990?
Offer a terse response. 0.89. What is the ratio of the Number of teachers in Panama in 1989 to that in 1990?
Give a very brief answer. 0.99. What is the ratio of the Number of teachers of Tunisia in 1989 to that in 1990?
Make the answer very short. 0.95. What is the ratio of the Number of teachers of Madagascar in 1989 to that in 1999?
Your answer should be compact. 0.89. What is the ratio of the Number of teachers in Myanmar in 1989 to that in 1999?
Offer a very short reply. 0.62. What is the ratio of the Number of teachers of Panama in 1989 to that in 1999?
Your answer should be compact. 1. What is the ratio of the Number of teachers in Tunisia in 1989 to that in 1999?
Your response must be concise. 0.73. What is the ratio of the Number of teachers in Madagascar in 1990 to that in 1999?
Provide a succinct answer. 0.89. What is the ratio of the Number of teachers in Myanmar in 1990 to that in 1999?
Offer a terse response. 0.7. What is the ratio of the Number of teachers in Panama in 1990 to that in 1999?
Make the answer very short. 1.01. What is the ratio of the Number of teachers in Tunisia in 1990 to that in 1999?
Give a very brief answer. 0.77. What is the difference between the highest and the second highest Number of teachers of Madagascar?
Give a very brief answer. 741. What is the difference between the highest and the second highest Number of teachers in Myanmar?
Offer a terse response. 4.68e+04. What is the difference between the highest and the second highest Number of teachers of Panama?
Your answer should be very brief. 180. What is the difference between the highest and the second highest Number of teachers in Tunisia?
Provide a short and direct response. 1.41e+04. What is the difference between the highest and the lowest Number of teachers of Madagascar?
Provide a short and direct response. 6459. What is the difference between the highest and the lowest Number of teachers in Myanmar?
Offer a terse response. 7.64e+04. What is the difference between the highest and the lowest Number of teachers of Panama?
Your answer should be very brief. 2396. What is the difference between the highest and the lowest Number of teachers of Tunisia?
Provide a succinct answer. 3.17e+04. 